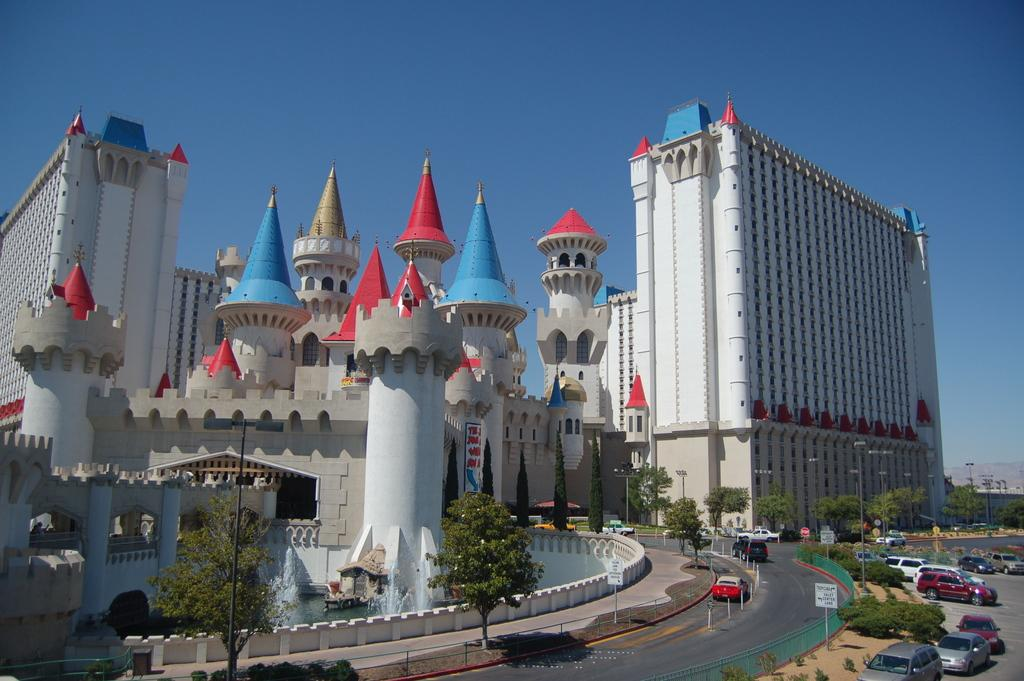What can be seen on the ground in the image? There is a group of vehicles on the ground in the image. What type of vegetation is present in the image? There are plants and trees in the image. What structures can be seen in the image? There are poles, sign boards, and buildings with windows in the image. What is visible in the background of the image? The sky is visible in the image, and it appears cloudy. Can you tell me how many ants are crawling on the picture in the image? There are no ants present in the image; it features a group of vehicles, plants, trees, poles, sign boards, buildings, and a cloudy sky. What is the stomach condition of the person holding the picture in the image? There is no person holding a picture in the image, so it is not possible to determine their stomach condition. 